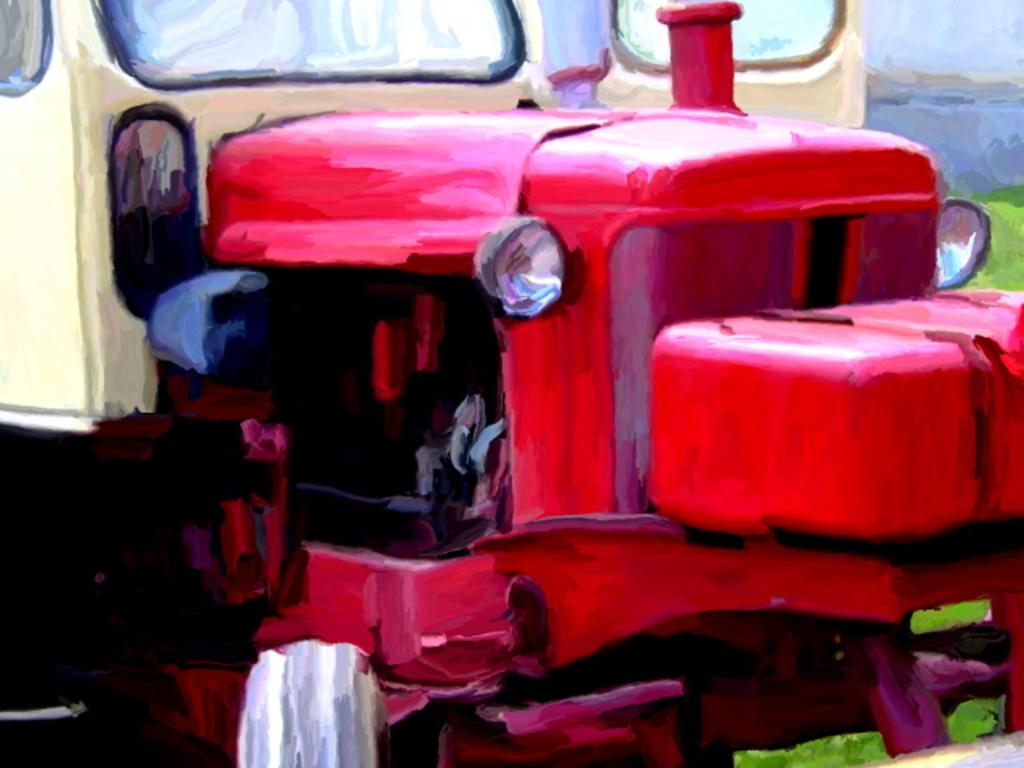What type of artwork is the image? The image is a painting. What is the main subject of the painting? The painting depicts a vehicle. How many frogs are included in the caption of the painting? There is no caption present in the painting, and therefore no frogs can be included in it. 